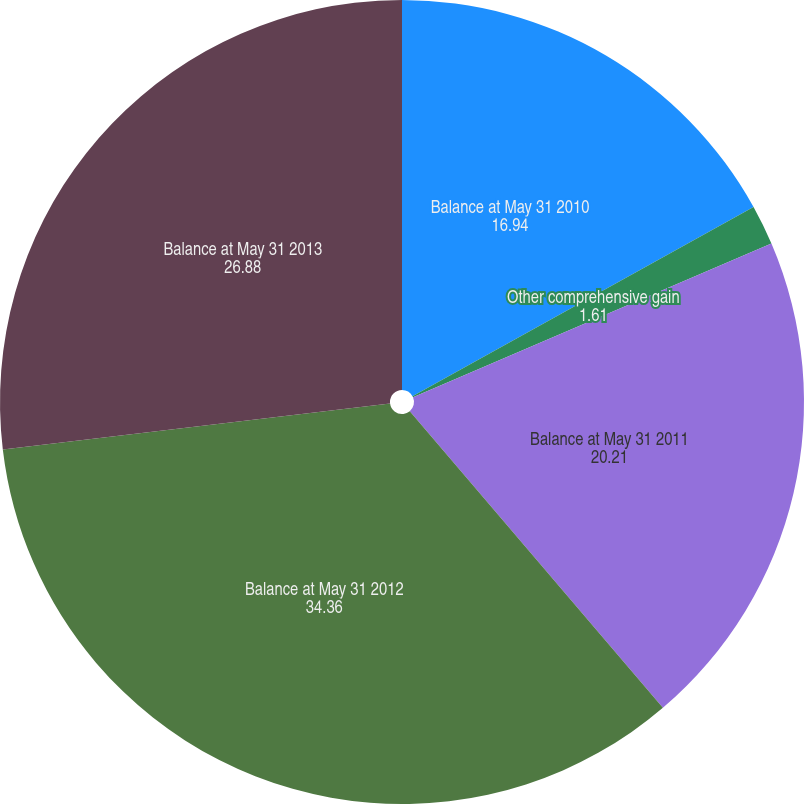<chart> <loc_0><loc_0><loc_500><loc_500><pie_chart><fcel>Balance at May 31 2010<fcel>Other comprehensive gain<fcel>Balance at May 31 2011<fcel>Balance at May 31 2012<fcel>Balance at May 31 2013<nl><fcel>16.94%<fcel>1.61%<fcel>20.21%<fcel>34.36%<fcel>26.88%<nl></chart> 